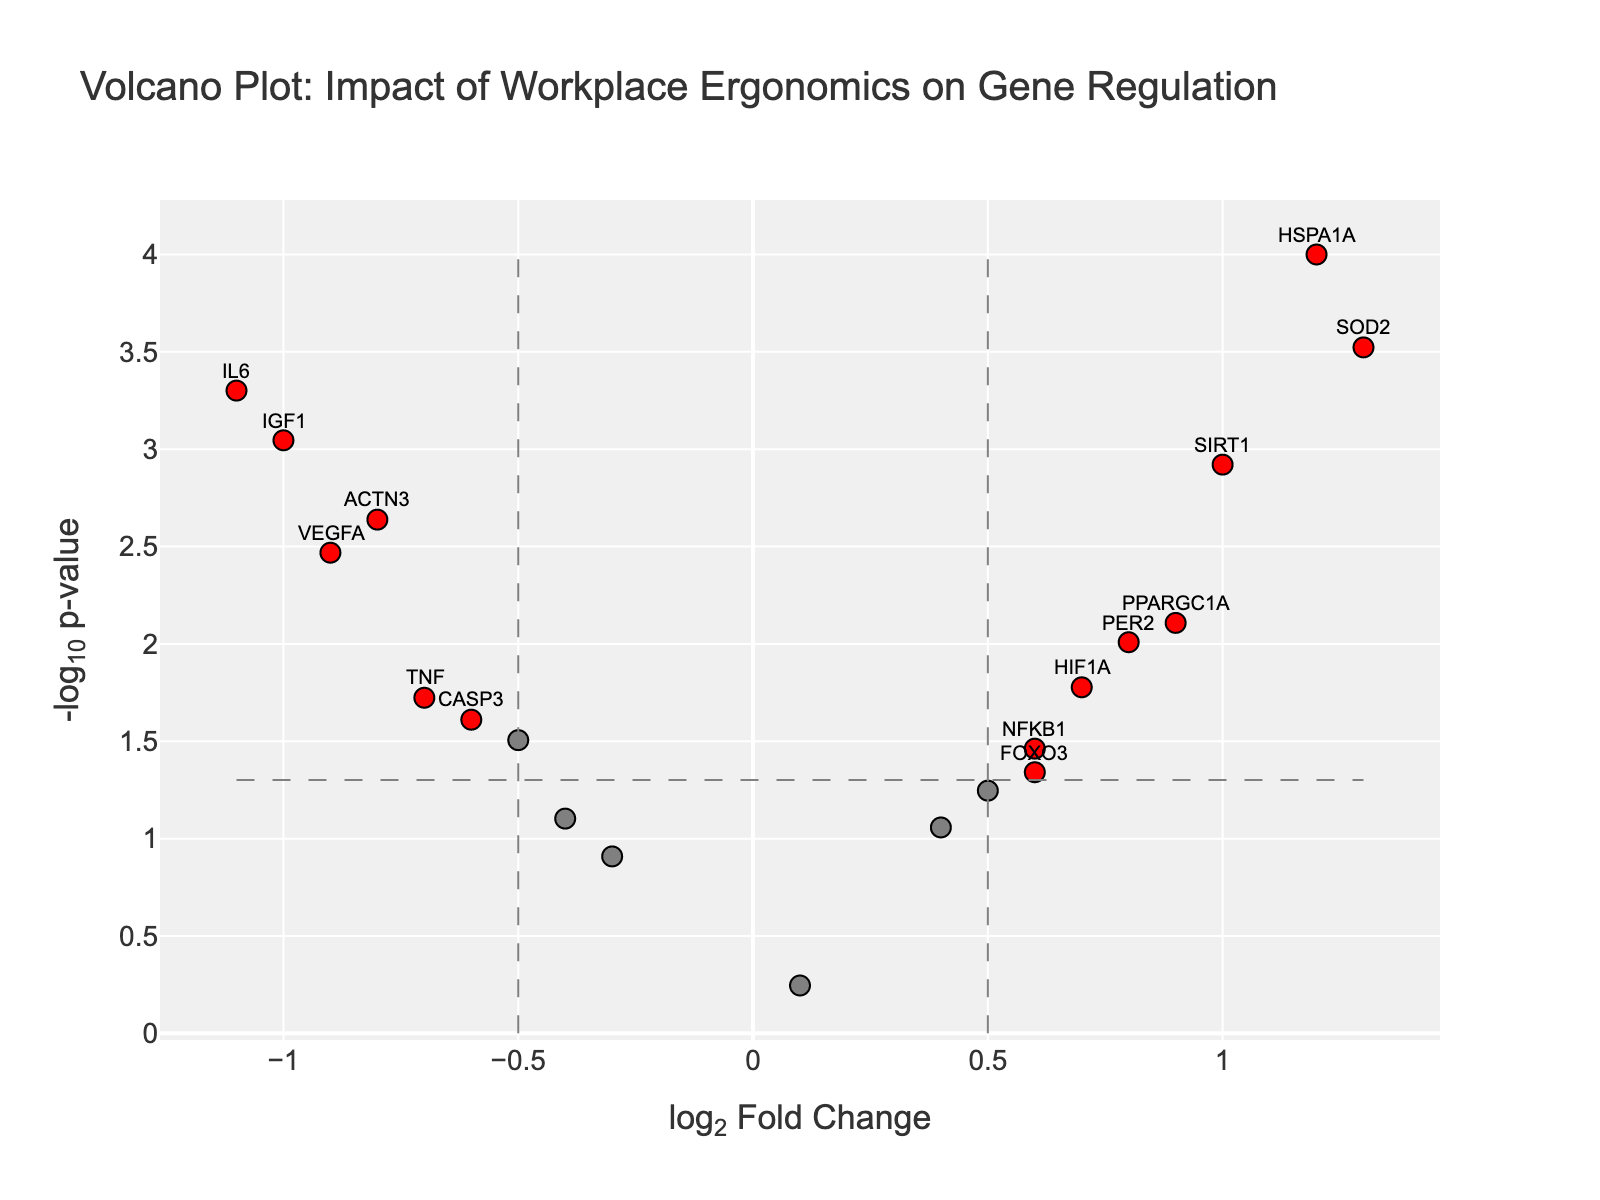What is the title of the figure? The title can be found at the top of the figure, which typically describes the main topic or content of the plot.
Answer: Volcano Plot: Impact of Workplace Ergonomics on Gene Regulation Which gene has the highest log2FoldChange? By observing the x-axis values, we can locate the gene with the highest positive log2FoldChange.
Answer: SOD2 What is the p-value for the gene ACTN3? Hovering over the data point or observing the hover text reveals the p-value associated with the gene ACTN3.
Answer: 0.0023 How many genes are considered significant based on the thresholds provided? The significant genes are identified by their red color. Counting the red points gives the total number of significant genes.
Answer: 11 Which gene has the lowest -log10(pValue), and what is its approximate value? The lowest -log10(pValue) can be found by identifying the smallest value on the y-axis. Hovering over or inspecting the hover text can confirm the gene.
Answer: GAPDH, approximately -0.25 Are there more upregulated or downregulated significant genes? Significant genes are colored red. Check the position on the x-axis to identify if they are upregulated (positive) or downregulated (negative).
Answer: Upregulated What is the log2FoldChange for the gene with the highest -log10(pValue)? Identify the point with the highest y-axis value, hover over it to get the gene name and log2FoldChange.
Answer: HSPA1A, with log2FoldChange of 1.2 Which genes are near the vertical significance threshold lines but not considered significant? Genes near ±0.5 on the x-axis and above the horizontal line but not colored red can be identified.
Answer: CLOCK, MTOR, TP53, MAPK1, GAPDH What does the red color represent in this plot? Red color indicates significant genes, identified by log2FoldChange above ±0.5 and p-value below 0.05.
Answer: Significant genes What is the approximate -log10(pValue) for VEGFA, and was it significantly impacted by workplace ergonomics? Locate the gene VEGFA in the plot, hover over it or check for red color and read the y-axis value. The significance is determined if it is red.
Answer: Approximately 2.47, and yes, significantly impacted 